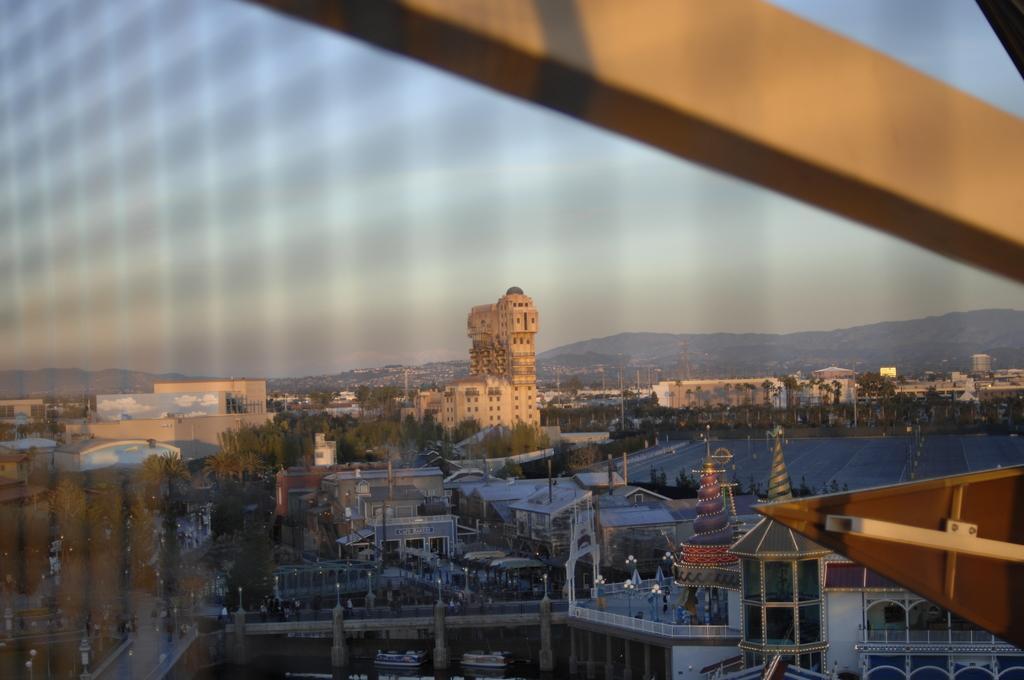Please provide a concise description of this image. In this picture i can see many buildings. On the right there is a water, beside that i can see the road and trees. In the background i can see the mountains. On the left there is a sky. At the top there is a steel rod. 